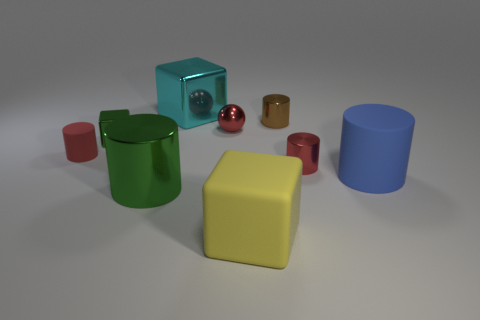Are there fewer shiny cylinders than shiny things?
Keep it short and to the point. Yes. There is a metallic cylinder behind the red matte thing; what color is it?
Ensure brevity in your answer.  Brown. What is the object that is in front of the red shiny cylinder and behind the big green metallic object made of?
Provide a succinct answer. Rubber. The red thing that is the same material as the blue cylinder is what shape?
Provide a short and direct response. Cylinder. What number of red cylinders are to the right of the tiny red cylinder that is left of the cyan metal block?
Your answer should be very brief. 1. How many objects are both to the left of the tiny metallic ball and behind the red metallic ball?
Provide a short and direct response. 1. What number of other objects are the same material as the big blue cylinder?
Provide a short and direct response. 2. What is the color of the object on the right side of the red metal thing to the right of the yellow rubber block?
Keep it short and to the point. Blue. Do the tiny metal cylinder that is on the right side of the brown thing and the ball have the same color?
Provide a short and direct response. Yes. Do the shiny ball and the cyan cube have the same size?
Keep it short and to the point. No. 